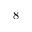Convert formula to latex. <formula><loc_0><loc_0><loc_500><loc_500>8</formula> 